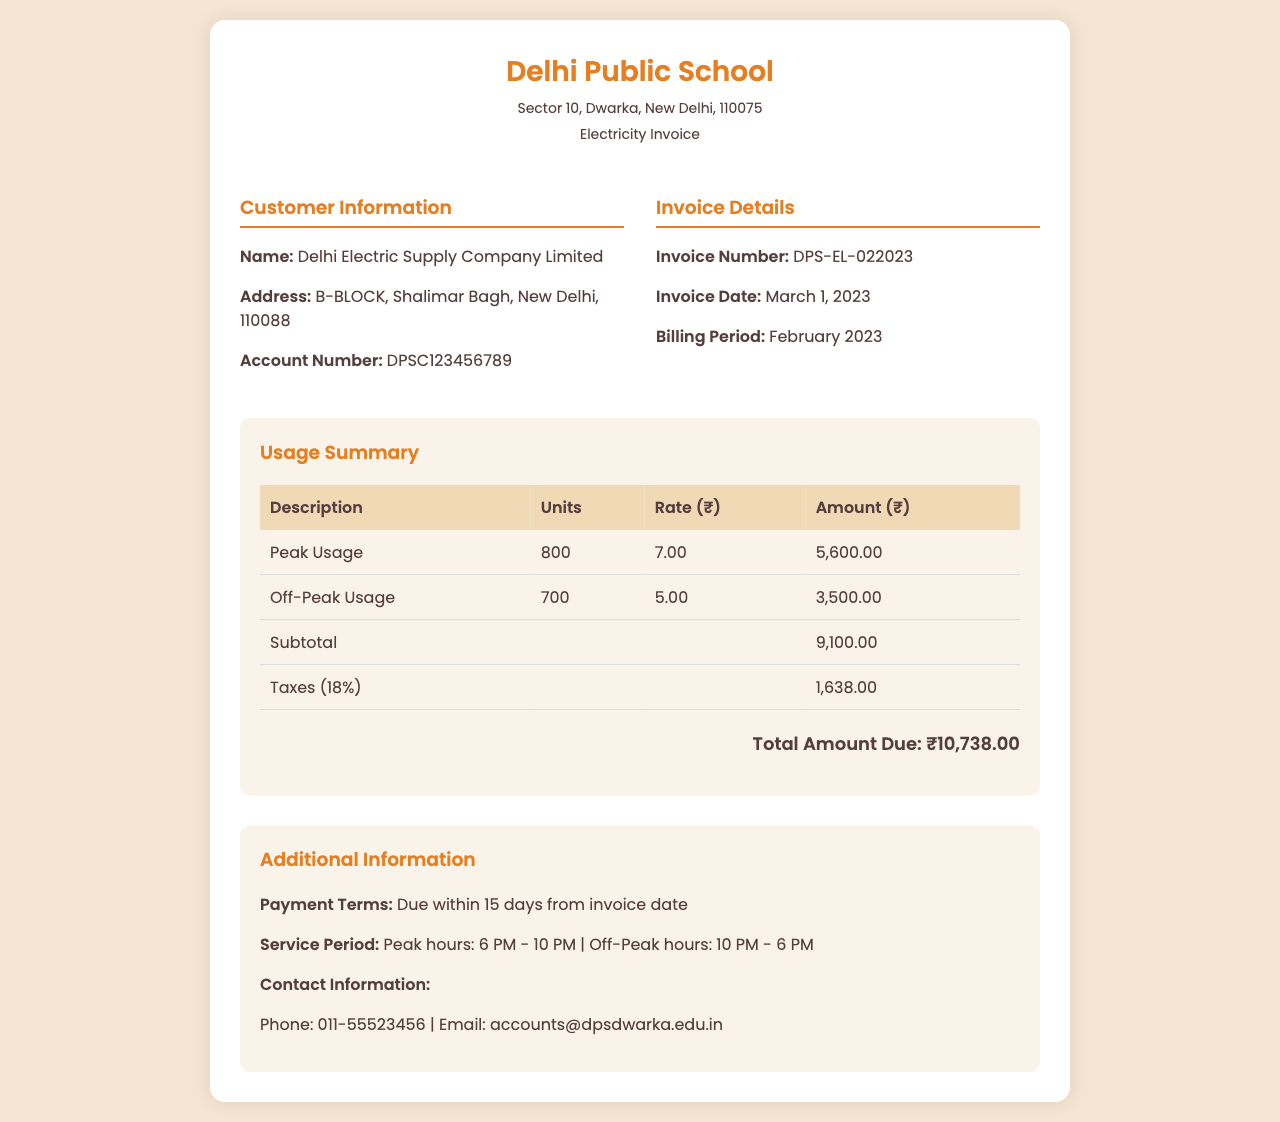What is the invoice number? The invoice number is listed in the invoice details section of the document.
Answer: DPS-EL-022023 What is the total amount due? The total amount due is clearly stated at the end of the usage summary section of the invoice.
Answer: ₹10,738.00 How many units were consumed during off-peak usage? The off-peak usage section provides the number of units consumed during that period.
Answer: 700 What is the rate for peak usage? The rate for peak usage can be found in the usage summary table under the peak usage row.
Answer: 7.00 What is the tax percentage applied? The taxes section of the usage summary indicates the percentage applied for tax calculations.
Answer: 18% Which company issued this invoice? The customer information section states the name of the company that issued the invoice.
Answer: Delhi Electric Supply Company Limited What is the billing period? The billing period is specified in the invoice details section of the document.
Answer: February 2023 What is the due date for payment? The payment terms section mentions when the payment is due after the invoice date.
Answer: Due within 15 days from invoice date During which hours is peak usage defined? The service period section outlines the specific hours classified as peak usage.
Answer: 6 PM - 10 PM 